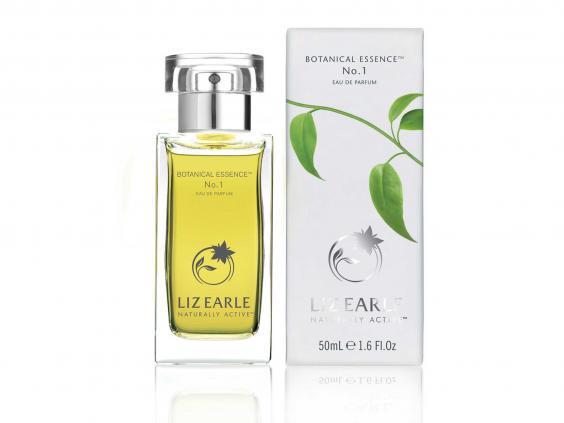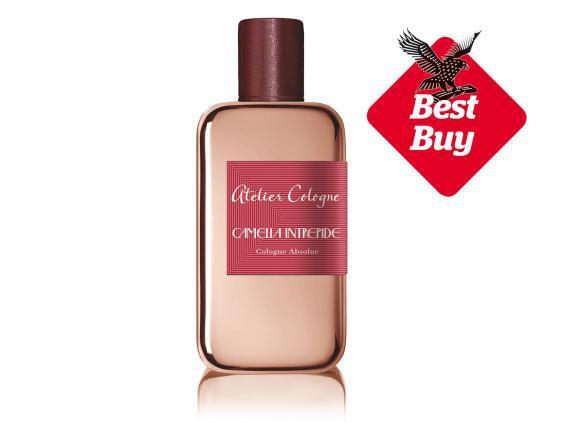The first image is the image on the left, the second image is the image on the right. Evaluate the accuracy of this statement regarding the images: "There is a single glass bottle of perfume next to it's box with a clear cap". Is it true? Answer yes or no. Yes. The first image is the image on the left, the second image is the image on the right. For the images shown, is this caption "One image shows exactly one fragrance bottle next to its box but not overlapping it." true? Answer yes or no. Yes. 